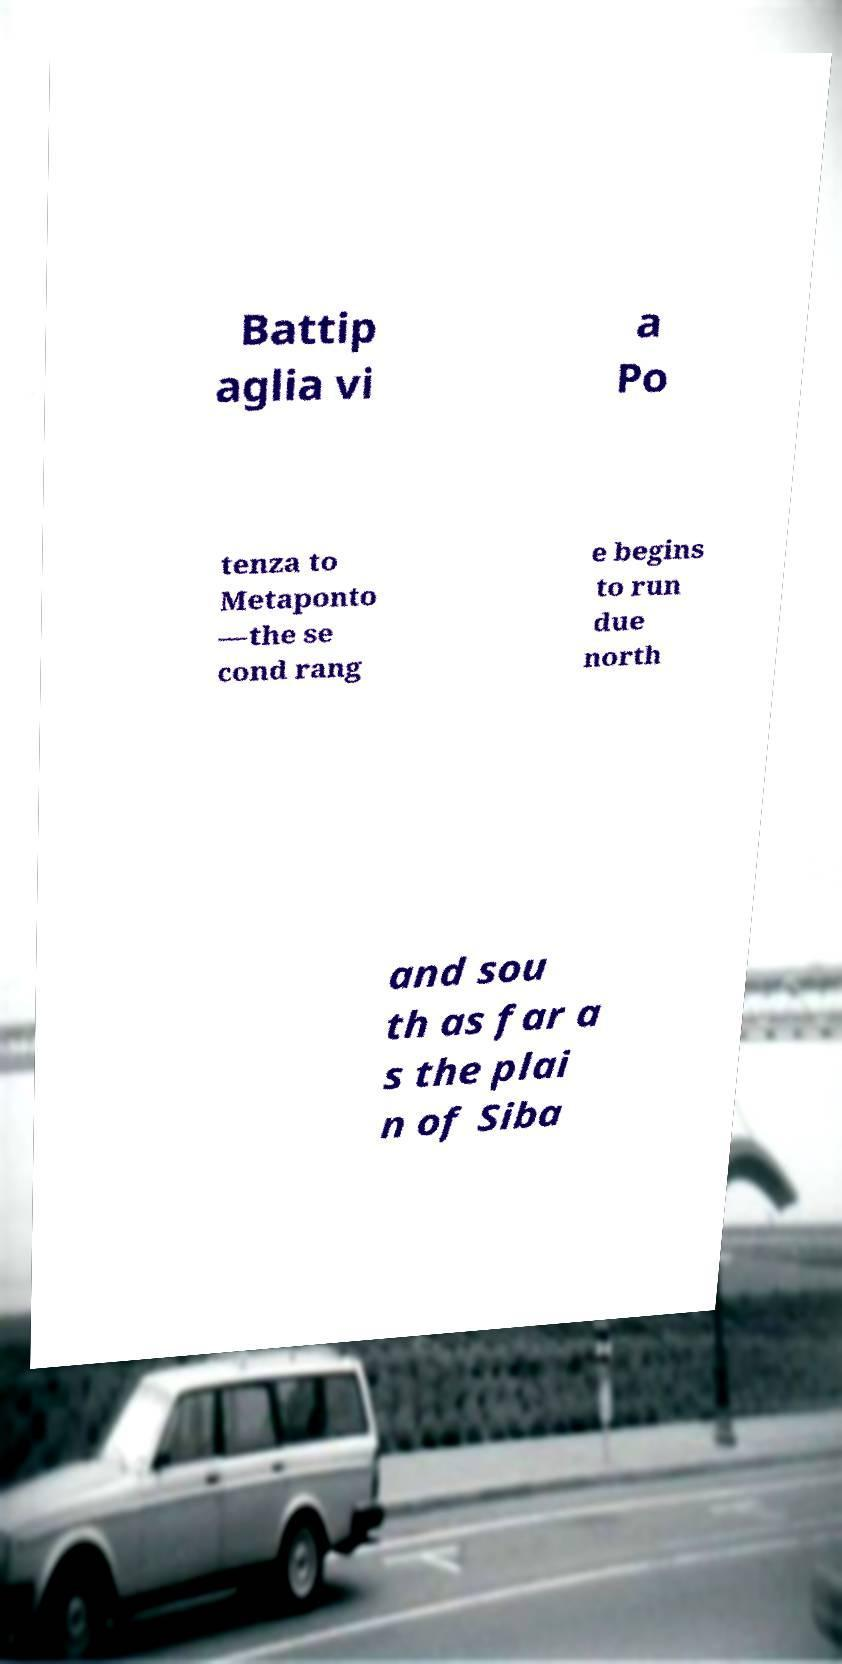Please identify and transcribe the text found in this image. Battip aglia vi a Po tenza to Metaponto —the se cond rang e begins to run due north and sou th as far a s the plai n of Siba 